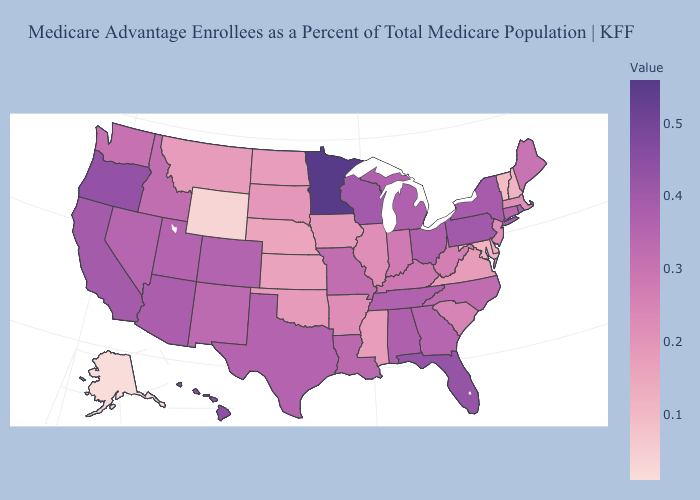Which states have the highest value in the USA?
Quick response, please. Minnesota. Which states have the highest value in the USA?
Give a very brief answer. Minnesota. Which states have the highest value in the USA?
Write a very short answer. Minnesota. Does Tennessee have a higher value than Nebraska?
Be succinct. Yes. Which states have the lowest value in the USA?
Concise answer only. Alaska. Is the legend a continuous bar?
Be succinct. Yes. Does Alaska have a lower value than Montana?
Concise answer only. Yes. Among the states that border Alabama , does Florida have the lowest value?
Short answer required. No. 